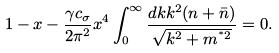<formula> <loc_0><loc_0><loc_500><loc_500>1 - x - \frac { \gamma c _ { \sigma } } { 2 \pi ^ { 2 } } x ^ { 4 } \int ^ { \infty } _ { 0 } \frac { d k k ^ { 2 } ( n + \bar { n } ) } { \sqrt { k ^ { 2 } + m ^ { ^ { * } 2 } } } = 0 .</formula> 